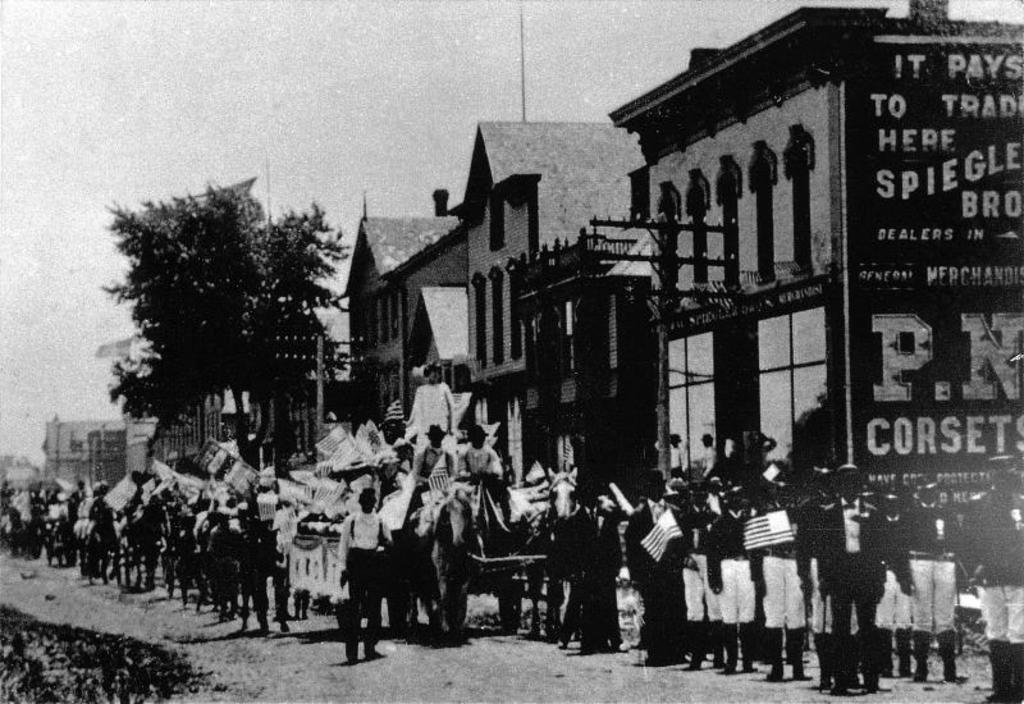Could you give a brief overview of what you see in this image? In this image people are standing by holding the flags. At the back side there are buildings, trees and sky. 